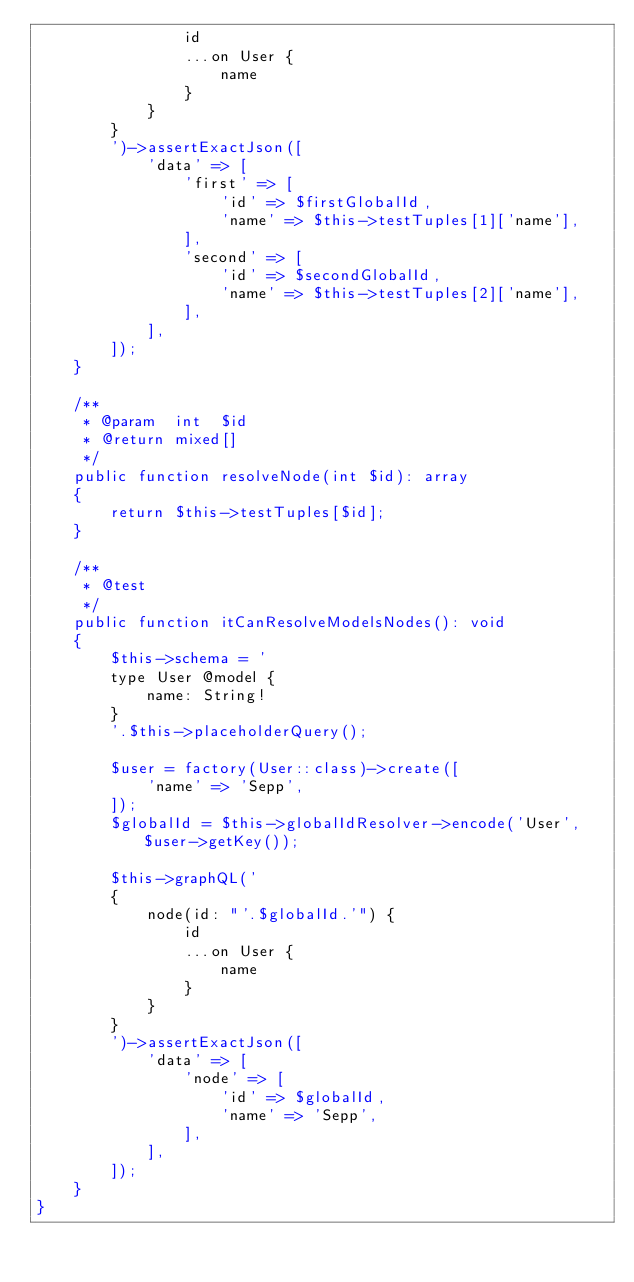<code> <loc_0><loc_0><loc_500><loc_500><_PHP_>                id
                ...on User {
                    name
                }
            }
        }
        ')->assertExactJson([
            'data' => [
                'first' => [
                    'id' => $firstGlobalId,
                    'name' => $this->testTuples[1]['name'],
                ],
                'second' => [
                    'id' => $secondGlobalId,
                    'name' => $this->testTuples[2]['name'],
                ],
            ],
        ]);
    }

    /**
     * @param  int  $id
     * @return mixed[]
     */
    public function resolveNode(int $id): array
    {
        return $this->testTuples[$id];
    }

    /**
     * @test
     */
    public function itCanResolveModelsNodes(): void
    {
        $this->schema = '
        type User @model {
            name: String!
        }
        '.$this->placeholderQuery();

        $user = factory(User::class)->create([
            'name' => 'Sepp',
        ]);
        $globalId = $this->globalIdResolver->encode('User', $user->getKey());

        $this->graphQL('
        {
            node(id: "'.$globalId.'") {
                id
                ...on User {
                    name
                }
            }
        }
        ')->assertExactJson([
            'data' => [
                'node' => [
                    'id' => $globalId,
                    'name' => 'Sepp',
                ],
            ],
        ]);
    }
}
</code> 